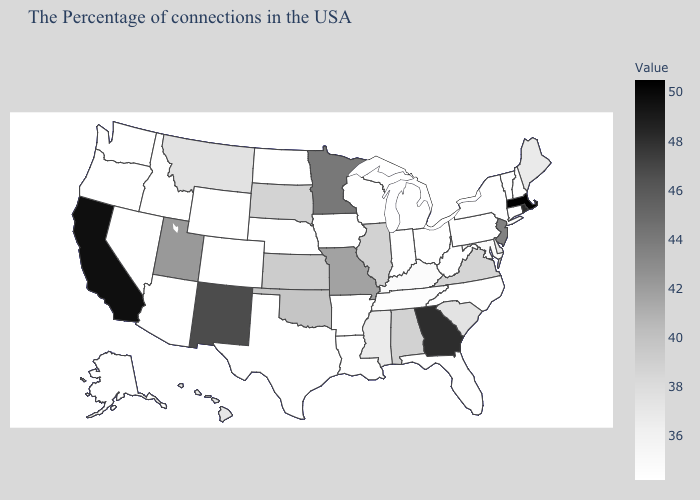Is the legend a continuous bar?
Answer briefly. Yes. Does Missouri have the lowest value in the MidWest?
Answer briefly. No. Does New Mexico have a lower value than Pennsylvania?
Answer briefly. No. Which states hav the highest value in the South?
Answer briefly. Georgia. Does North Dakota have a lower value than Montana?
Give a very brief answer. Yes. Is the legend a continuous bar?
Short answer required. Yes. Does Vermont have the lowest value in the USA?
Concise answer only. Yes. 